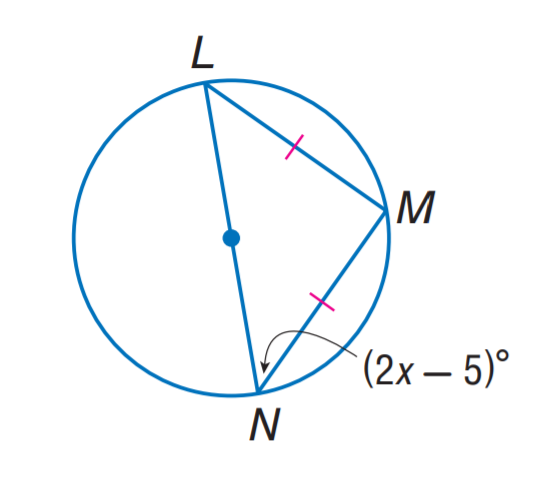Question: Find x.
Choices:
A. 25
B. 30
C. 35
D. 45
Answer with the letter. Answer: A 